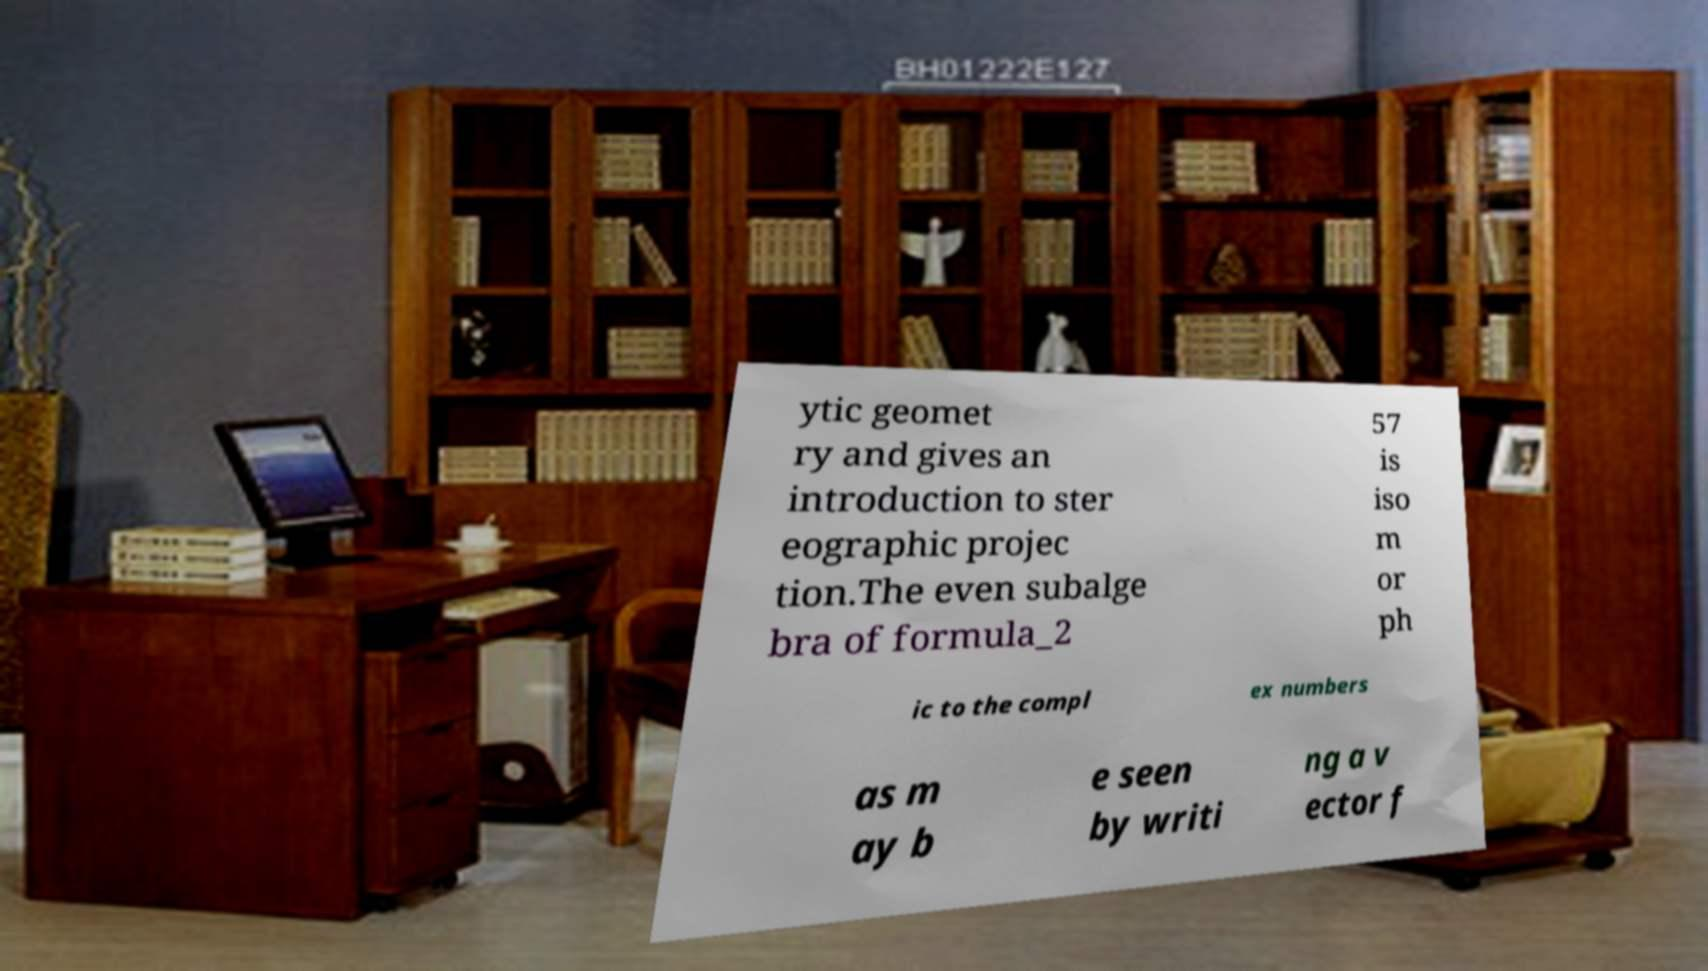Please identify and transcribe the text found in this image. ytic geomet ry and gives an introduction to ster eographic projec tion.The even subalge bra of formula_2 57 is iso m or ph ic to the compl ex numbers as m ay b e seen by writi ng a v ector f 